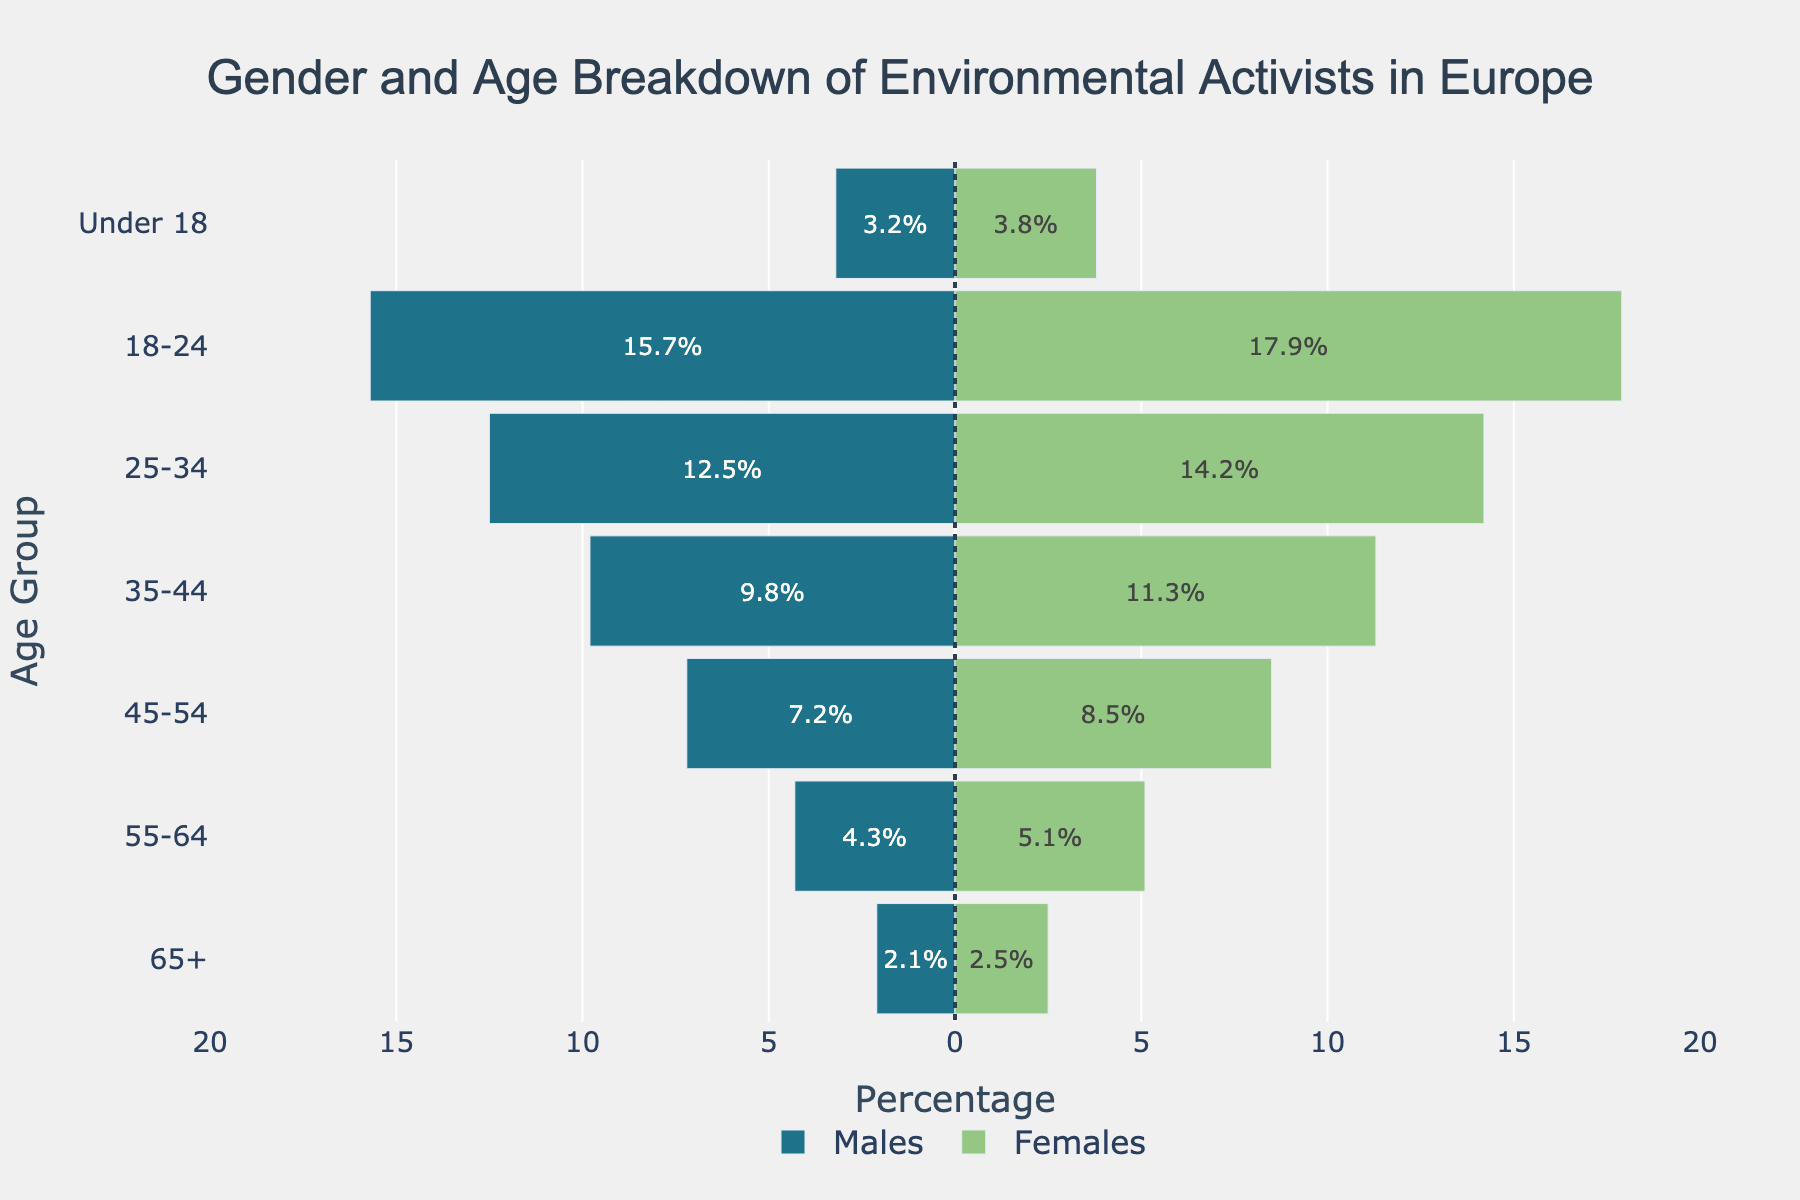What is the percentage of female environmental activists aged 18-24? Look at the bar representing the '18-24' age group on the female side of the population pyramid. The percentage value is directly displayed inside the bar.
Answer: 17.9% How much higher is the percentage of female activists aged 35-44 compared to male activists in the same age group? First, locate the bars for the age group '35-44' for both males and females. The percentage for males is 9.8% and for females is 11.3%. Subtract the male value from the female value: 11.3% - 9.8% = 1.5%
Answer: 1.5% What age group has the highest percentage of male environmental activists? Look for the longest bar on the male side of the population pyramid. The longest bar corresponds to the '18-24' age group.
Answer: 18-24 Which age group shows a higher percentage of female activists and by how much compared to the males in the same group? Compare the lengths of the bars for each age group across males and females. The '18-24' age group has the highest difference, where females are at 17.9% and males at 15.7%. The difference is 17.9% - 15.7% = 2.2%
Answer: 18-24, 2.2% Calculate the total percentage of environmental activists aged 25-34 for both genders combined. Locate the '25-34' age group bars on both the male and female sides. The percentages are 12.5% for males and 14.2% for females. Add these values together: 12.5% + 14.2% = 26.7%
Answer: 26.7% In which age group do environmental activists have the least gender disparity? Examine the differences in percentages between males and females for each age group. The '65+' age group has the smallest difference: 2.5% - 2.1% = 0.4%
Answer: 65+ Is the percentage of male environmental activists under 18 higher or lower than those aged 55-64? Compare the bars for 'Under 18' and '55-64' on the male side. The percentage for 'Under 18' is 3.2%, and for '55-64', it is 4.3%. 3.2% is lower than 4.3%.
Answer: Lower What is the combined percentage of environmental activists aged 45+ (combining ages 45-54, 55-64, and 65+) among males? Add the percentages for the age groups '45-54', '55-64', and '65+' for males. 7.2% + 4.3% + 2.1% = 13.6%
Answer: 13.6% Which gender has a higher overall percentage of environmental activists in the '35-44' and '45-54' age groups combined? Calculate the total percentage for both age groups for each gender. For males: 9.8% (35-44) + 7.2% (45-54) = 17%. For females: 11.3% (35-44) + 8.5% (45-54) = 19.8%.
Answer: Females What is the percentage difference between the youngest and oldest age groups among female environmental activists? Subtract the percentage value for '65+' from the percentage value for 'Under 18' on the female side: 3.8% - 2.5% = 1.3%
Answer: 1.3% 